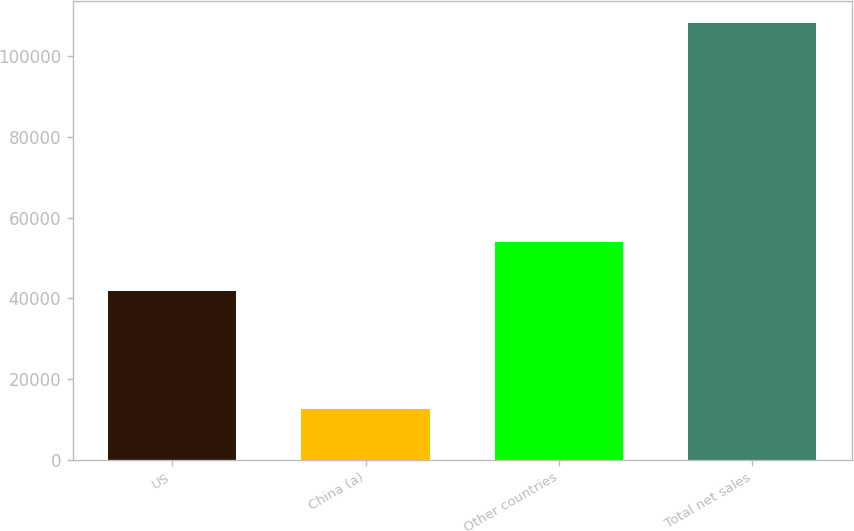Convert chart to OTSL. <chart><loc_0><loc_0><loc_500><loc_500><bar_chart><fcel>US<fcel>China (a)<fcel>Other countries<fcel>Total net sales<nl><fcel>41812<fcel>12472<fcel>53965<fcel>108249<nl></chart> 